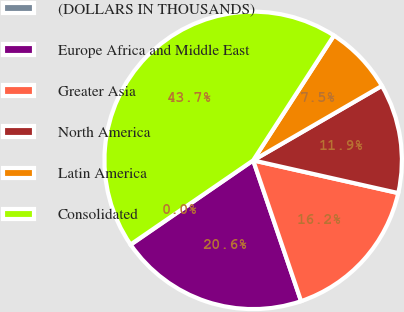Convert chart. <chart><loc_0><loc_0><loc_500><loc_500><pie_chart><fcel>(DOLLARS IN THOUSANDS)<fcel>Europe Africa and Middle East<fcel>Greater Asia<fcel>North America<fcel>Latin America<fcel>Consolidated<nl><fcel>0.03%<fcel>20.62%<fcel>16.25%<fcel>11.88%<fcel>7.51%<fcel>43.71%<nl></chart> 